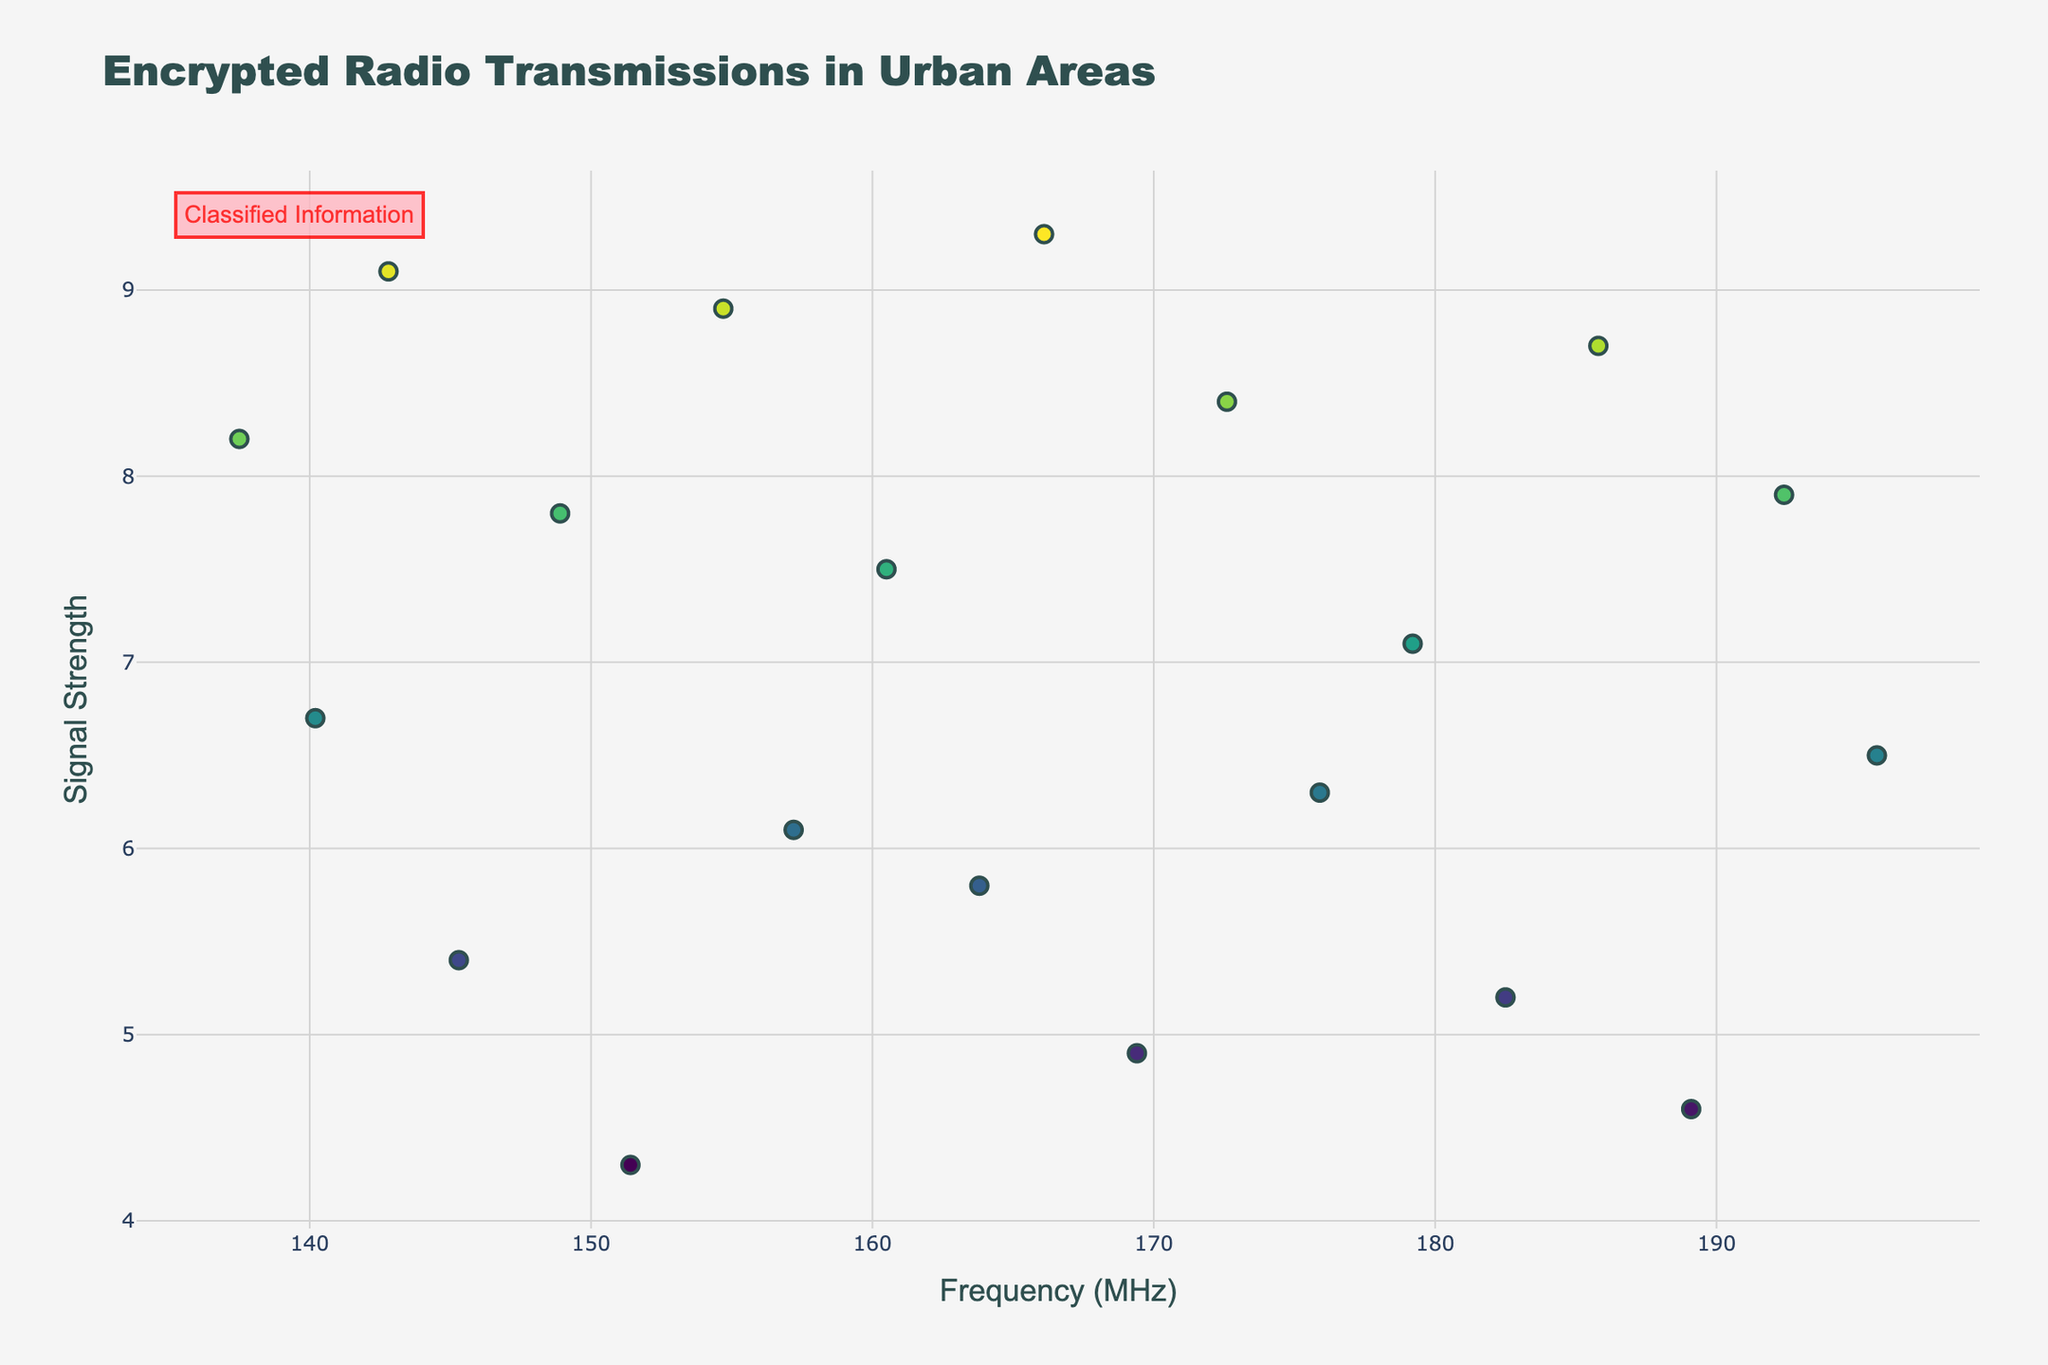Which frequency band has the highest signal strength? The highest data point in terms of signal strength appears around the frequency of 166.1 MHz.
Answer: 166.1 MHz What is the signal strength at Central Park? Locate "Central Park" on the plot's hover information. The corresponding signal strength is indicated as 8.2.
Answer: 8.2 How many data points are there in the plot? Count the number of markers displayed along the x-axis (frequency). Each marker represents a data point. There are 20 such markers.
Answer: 20 Which location has the lowest signal strength, and what is its value? Identify the marker with the lowest y-axis value. The hover information for this point is Grand Central Terminal, with a signal strength of 4.3.
Answer: Grand Central Terminal, 4.3 Which location is associated with a frequency of 148.9 MHz? Find the marker at 148.9 MHz on the x-axis and use the hover information or text to see the associated location. It is "Empire State Building."
Answer: Empire State Building What is the average signal strength across all measurements? Add all the signal strength values (8.2 + 6.7 + 9.1 + 5.4 + 7.8 + 4.3 + 8.9 + 6.1 + 7.5 + 5.8 + 9.3 + 4.9 + 8.4 + 6.3 + 7.1 + 5.2 + 8.7 + 4.6 + 7.9 + 6.5) and divide by the number of data points (20). The sum is 140.2, and the average is 140.2 / 20.
Answer: 7.01 Compare the signal strengths at One World Trade Center and NYPD Headquarters. Which one is higher and by how much? Find the values for both locations: One World Trade Center is 8.9 and NYPD Headquarters is 8.7. The difference is 8.9 - 8.7.
Answer: One World Trade Center, 0.2 How does the signal strength at the United Nations Headquarters compare to the signal strength at Grand Central Terminal? Locate both points: United Nations Headquarters has a signal strength of 5.8 and Grand Central Terminal is 4.3. 5.8 is greater than 4.3.
Answer: Greater What pattern can be observed regarding the distribution of signal strength across the frequency bands? Observing the plot, the signal strength does not show any clear increasing or decreasing trend with frequency, but there are peaks and troughs throughout the range.
Answer: Peaks and troughs What is the range of frequencies analyzed in this plot? Identify the minimum and maximum points on the x-axis, which represent the frequency. The range is from approximately 137.5 MHz to 195.7 MHz.
Answer: 137.5 MHz to 195.7 MHz 